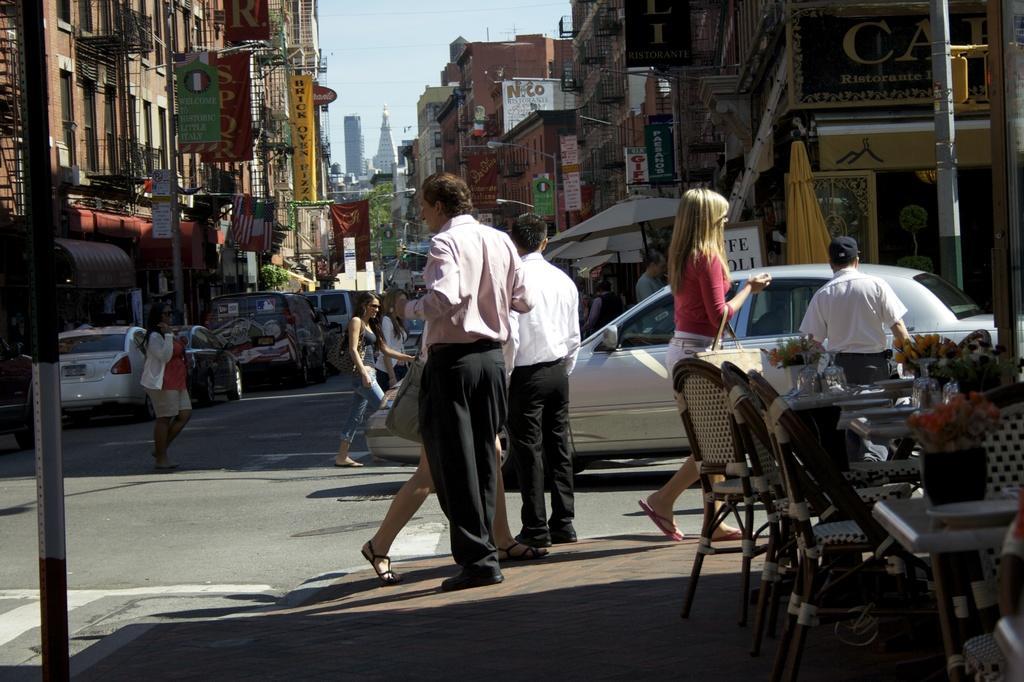Can you describe this image briefly? some people are walking across the street and there are few vehicles parked. 